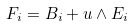Convert formula to latex. <formula><loc_0><loc_0><loc_500><loc_500>F _ { i } = B _ { i } + u \wedge E _ { i }</formula> 